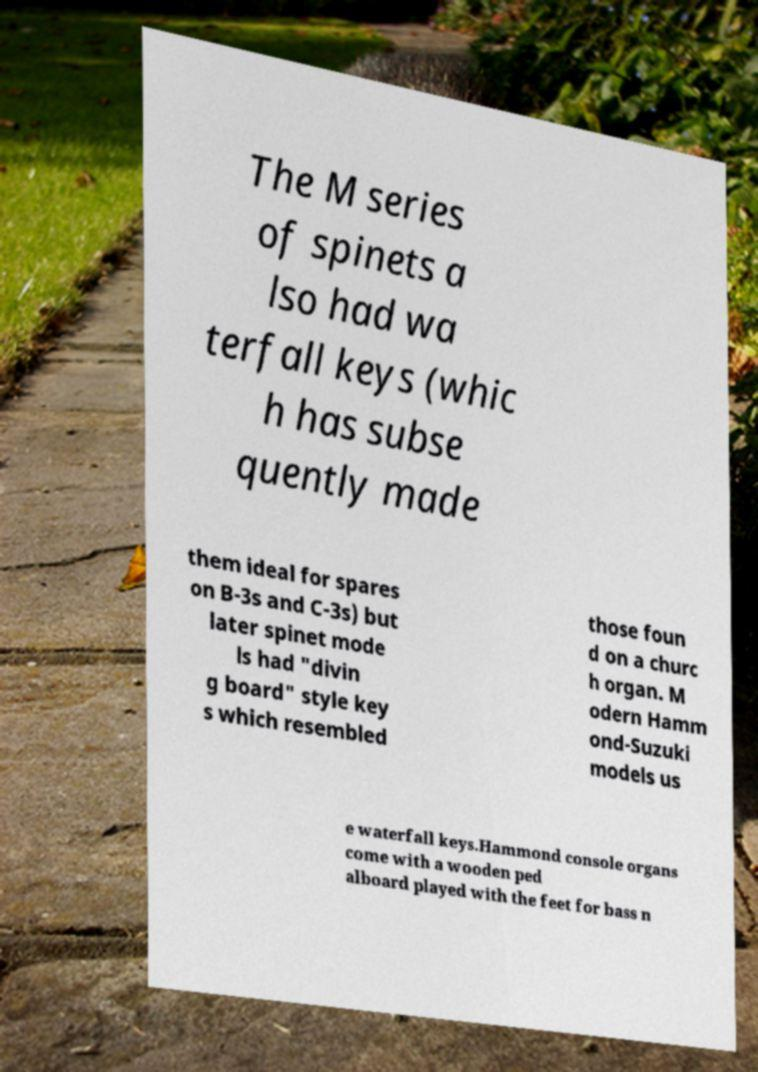Can you read and provide the text displayed in the image?This photo seems to have some interesting text. Can you extract and type it out for me? The M series of spinets a lso had wa terfall keys (whic h has subse quently made them ideal for spares on B-3s and C-3s) but later spinet mode ls had "divin g board" style key s which resembled those foun d on a churc h organ. M odern Hamm ond-Suzuki models us e waterfall keys.Hammond console organs come with a wooden ped alboard played with the feet for bass n 